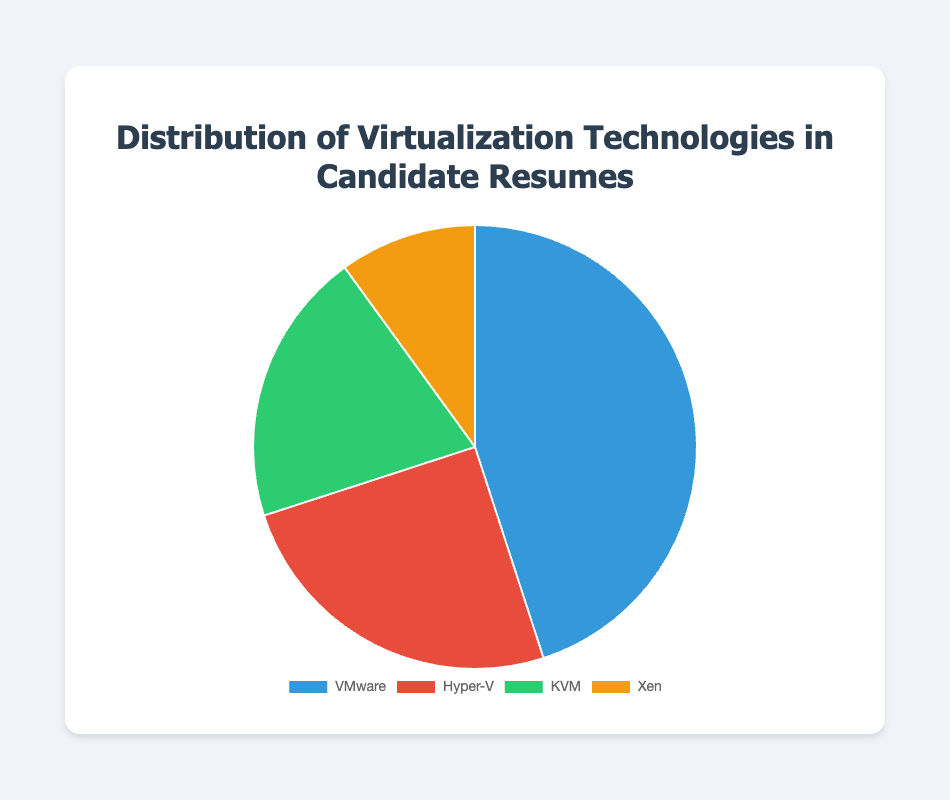What is the most popular virtualization technology among candidates? VMware is the largest slice in the pie chart, indicating it has the highest percentage.
Answer: VMware What percentage of candidates have Hyper-V experience compared to Xen? Hyper-V has a larger slice than Xen in the pie chart. Comparing their percentages, Hyper-V is 25% while Xen is 10%.
Answer: Hyper-V is more common Which virtualization technologies together account for more than half of the candidates' resumes? Adding the percentages of VMware (45%) and Hyper-V (25%), the total is 70%, which is more than half of 100%.
Answer: VMware and Hyper-V What is the combined percentage of candidates with KVM and Xen experience? The percentages are 20% for KVM and 10% for Xen. Summing these values gives 20% + 10% = 30%.
Answer: 30% Which technology has the smallest representation in candidate resumes? The smallest slice in the pie chart corresponds to Xen, which has the lowest percentage.
Answer: Xen By what percentage does VMware exceed Hyper-V in candidate resumes? VMware has 45% and Hyper-V has 25%. The excess percentage is 45% - 25% = 20%.
Answer: 20% What fraction of the pie chart is represented by technologies other than VMware? The other technologies are Hyper-V (25%), KVM (20%), and Xen (10%). Summing these gives 25% + 20% + 10% = 55%.
Answer: 55% How many times larger is VMware's share compared to Xen's in candidate resumes? VMware's share is 45%, and Xen's share is 10%. Dividing these percentages gives 45% / 10% = 4.5 times.
Answer: 4.5 times 